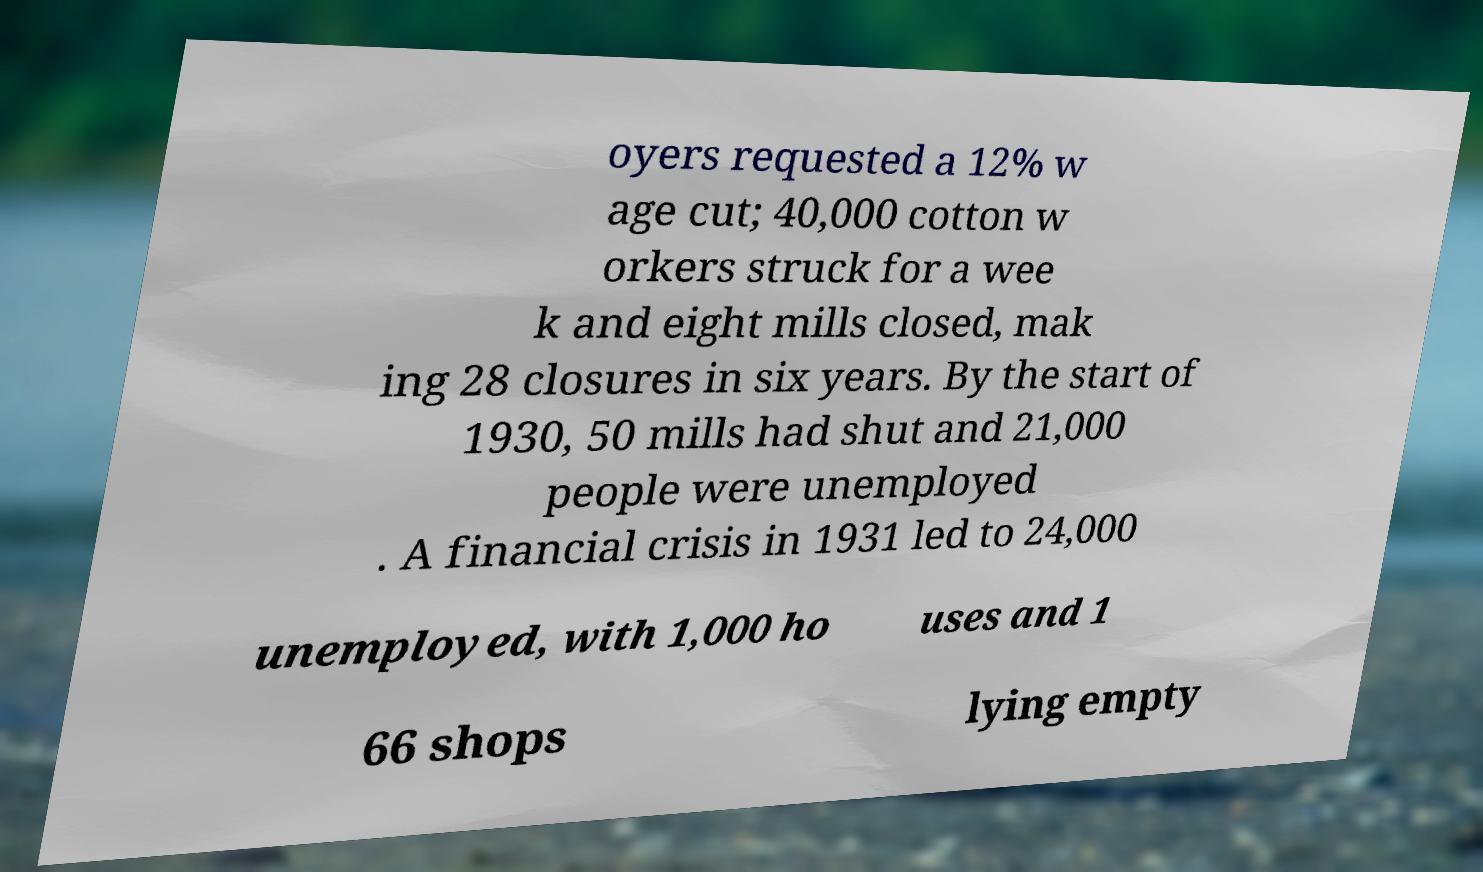What messages or text are displayed in this image? I need them in a readable, typed format. oyers requested a 12% w age cut; 40,000 cotton w orkers struck for a wee k and eight mills closed, mak ing 28 closures in six years. By the start of 1930, 50 mills had shut and 21,000 people were unemployed . A financial crisis in 1931 led to 24,000 unemployed, with 1,000 ho uses and 1 66 shops lying empty 